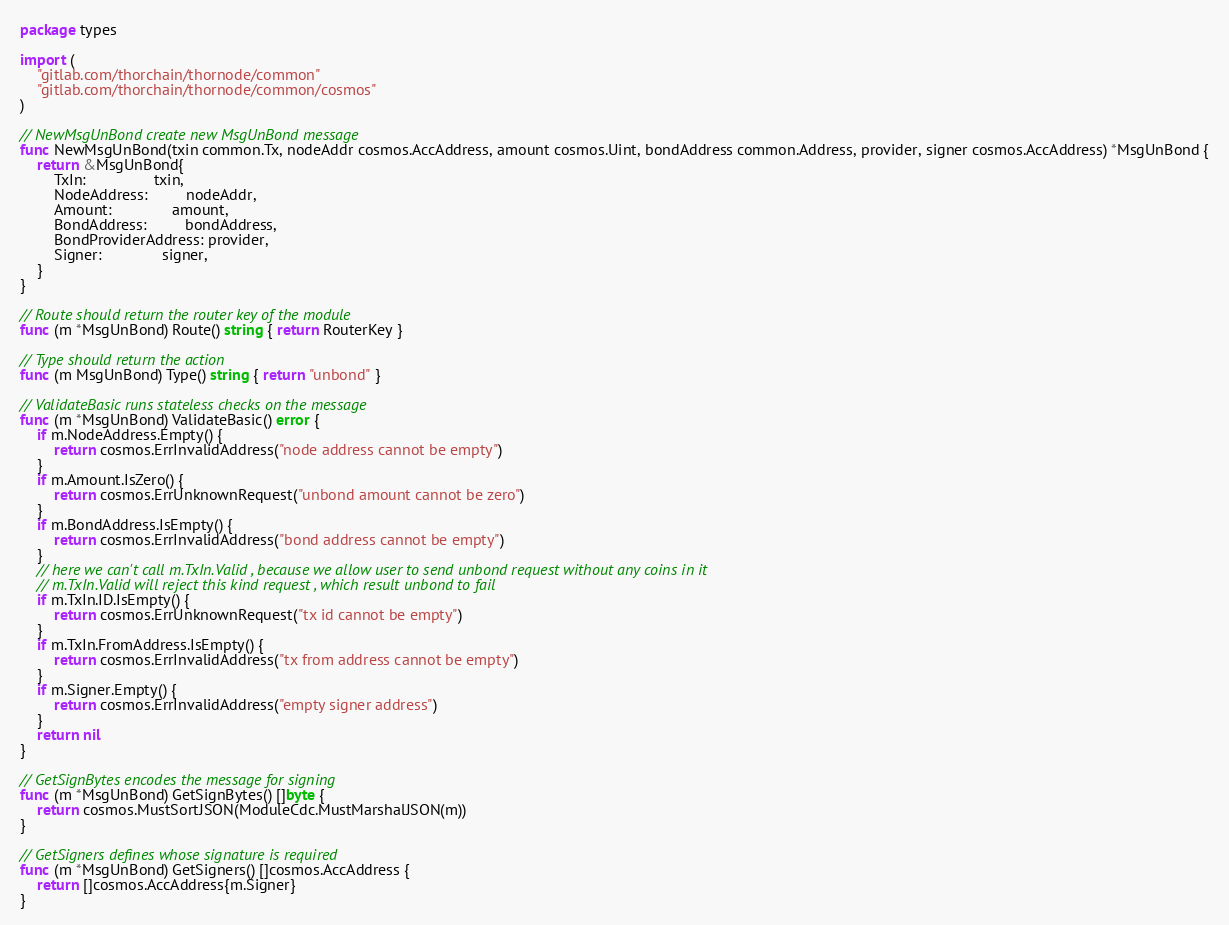<code> <loc_0><loc_0><loc_500><loc_500><_Go_>package types

import (
	"gitlab.com/thorchain/thornode/common"
	"gitlab.com/thorchain/thornode/common/cosmos"
)

// NewMsgUnBond create new MsgUnBond message
func NewMsgUnBond(txin common.Tx, nodeAddr cosmos.AccAddress, amount cosmos.Uint, bondAddress common.Address, provider, signer cosmos.AccAddress) *MsgUnBond {
	return &MsgUnBond{
		TxIn:                txin,
		NodeAddress:         nodeAddr,
		Amount:              amount,
		BondAddress:         bondAddress,
		BondProviderAddress: provider,
		Signer:              signer,
	}
}

// Route should return the router key of the module
func (m *MsgUnBond) Route() string { return RouterKey }

// Type should return the action
func (m MsgUnBond) Type() string { return "unbond" }

// ValidateBasic runs stateless checks on the message
func (m *MsgUnBond) ValidateBasic() error {
	if m.NodeAddress.Empty() {
		return cosmos.ErrInvalidAddress("node address cannot be empty")
	}
	if m.Amount.IsZero() {
		return cosmos.ErrUnknownRequest("unbond amount cannot be zero")
	}
	if m.BondAddress.IsEmpty() {
		return cosmos.ErrInvalidAddress("bond address cannot be empty")
	}
	// here we can't call m.TxIn.Valid , because we allow user to send unbond request without any coins in it
	// m.TxIn.Valid will reject this kind request , which result unbond to fail
	if m.TxIn.ID.IsEmpty() {
		return cosmos.ErrUnknownRequest("tx id cannot be empty")
	}
	if m.TxIn.FromAddress.IsEmpty() {
		return cosmos.ErrInvalidAddress("tx from address cannot be empty")
	}
	if m.Signer.Empty() {
		return cosmos.ErrInvalidAddress("empty signer address")
	}
	return nil
}

// GetSignBytes encodes the message for signing
func (m *MsgUnBond) GetSignBytes() []byte {
	return cosmos.MustSortJSON(ModuleCdc.MustMarshalJSON(m))
}

// GetSigners defines whose signature is required
func (m *MsgUnBond) GetSigners() []cosmos.AccAddress {
	return []cosmos.AccAddress{m.Signer}
}
</code> 